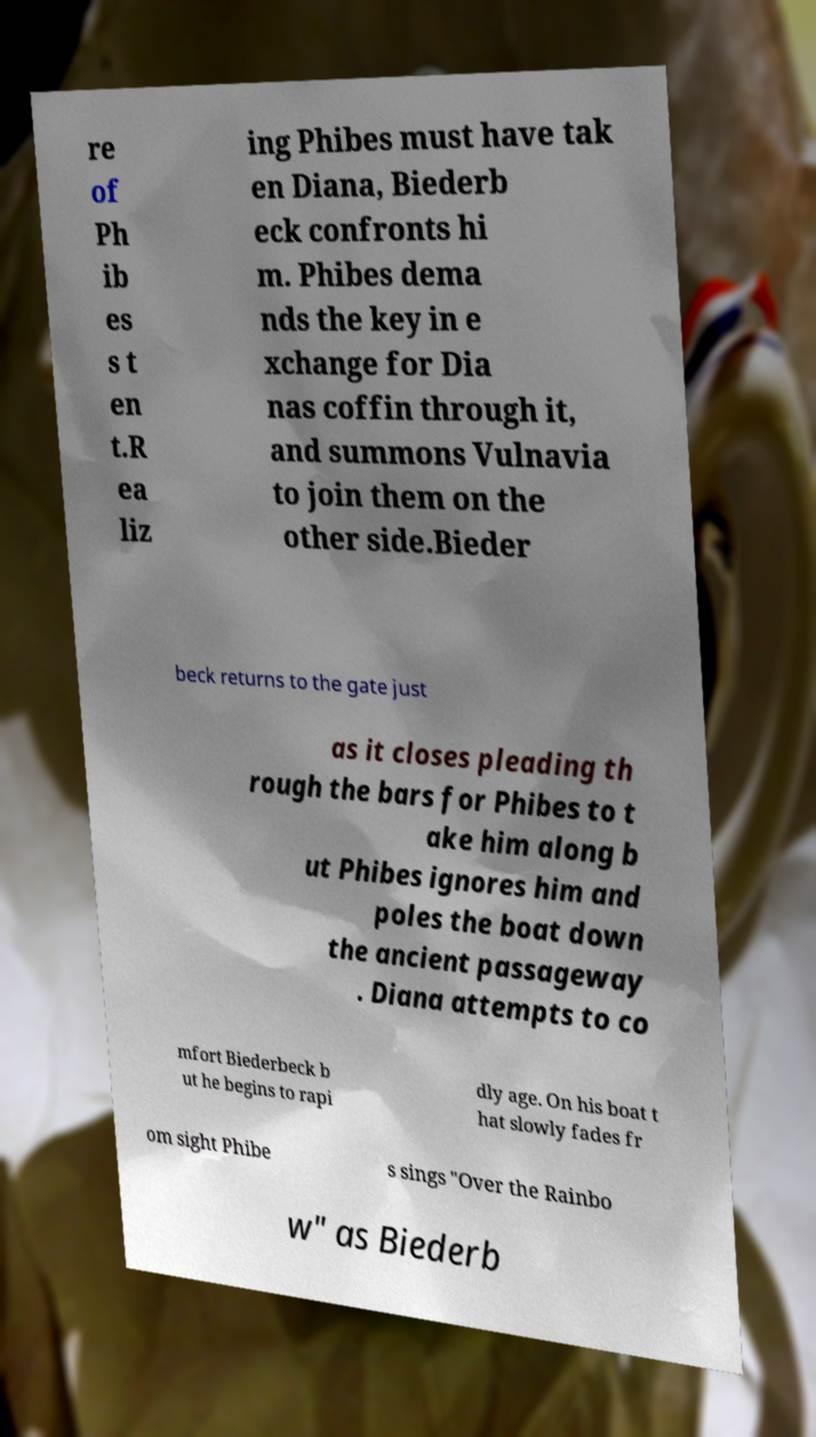Please read and relay the text visible in this image. What does it say? re of Ph ib es s t en t.R ea liz ing Phibes must have tak en Diana, Biederb eck confronts hi m. Phibes dema nds the key in e xchange for Dia nas coffin through it, and summons Vulnavia to join them on the other side.Bieder beck returns to the gate just as it closes pleading th rough the bars for Phibes to t ake him along b ut Phibes ignores him and poles the boat down the ancient passageway . Diana attempts to co mfort Biederbeck b ut he begins to rapi dly age. On his boat t hat slowly fades fr om sight Phibe s sings "Over the Rainbo w" as Biederb 